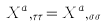Convert formula to latex. <formula><loc_0><loc_0><loc_500><loc_500>X ^ { a } , _ { \tau \tau } = X ^ { a } , _ { \sigma \sigma }</formula> 